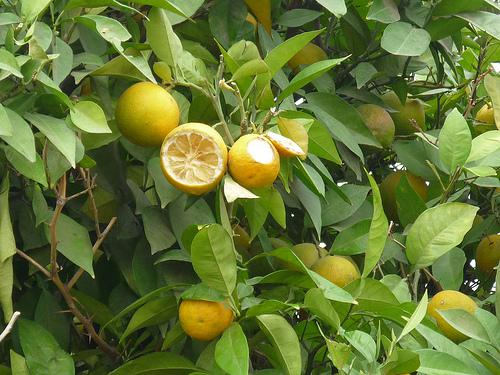Question: how ripe are these fruits?
Choices:
A. Not so ripe.
B. Almost ripe.
C. Slightly ripe.
D. Very ripe.
Answer with the letter. Answer: D Question: why are these fruit on a tree?
Choices:
A. They haven't been picked yet.
B. They haven't fallen off.
C. To be picked.
D. They grow that way.
Answer with the letter. Answer: D Question: how many fruits are there?
Choices:
A. 20.
B. 25.
C. 10.
D. 17.
Answer with the letter. Answer: D Question: how many fruit have been cut?
Choices:
A. 2.
B. 4.
C. 6.
D. 3.
Answer with the letter. Answer: D 